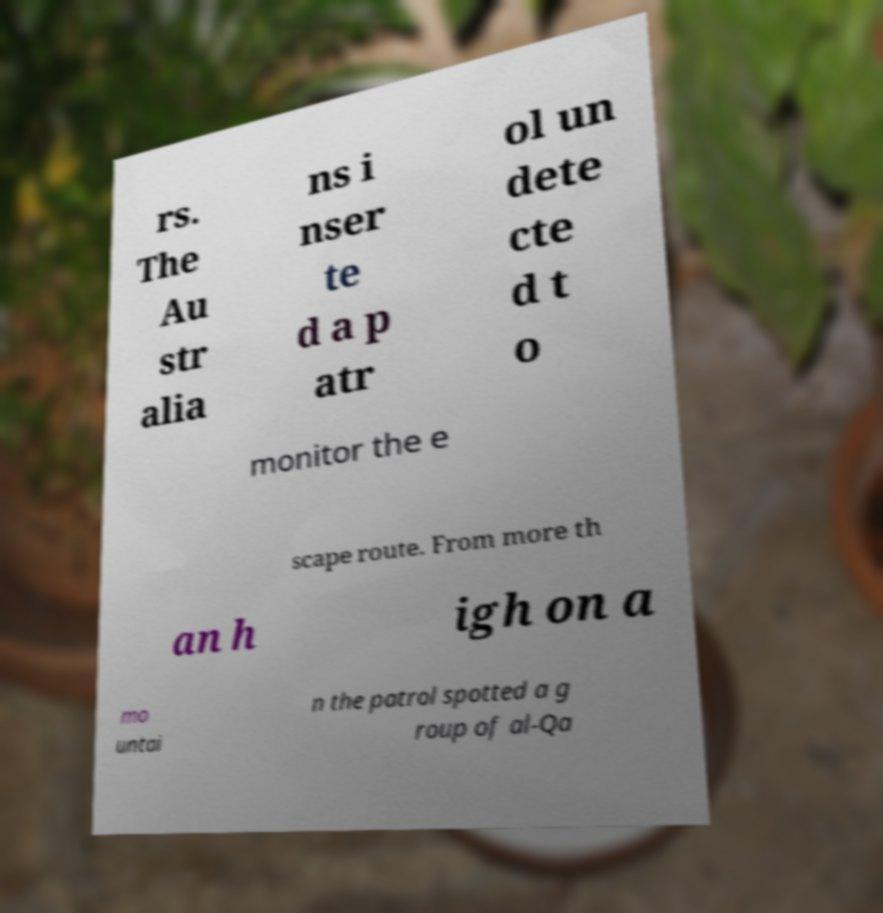There's text embedded in this image that I need extracted. Can you transcribe it verbatim? rs. The Au str alia ns i nser te d a p atr ol un dete cte d t o monitor the e scape route. From more th an h igh on a mo untai n the patrol spotted a g roup of al-Qa 